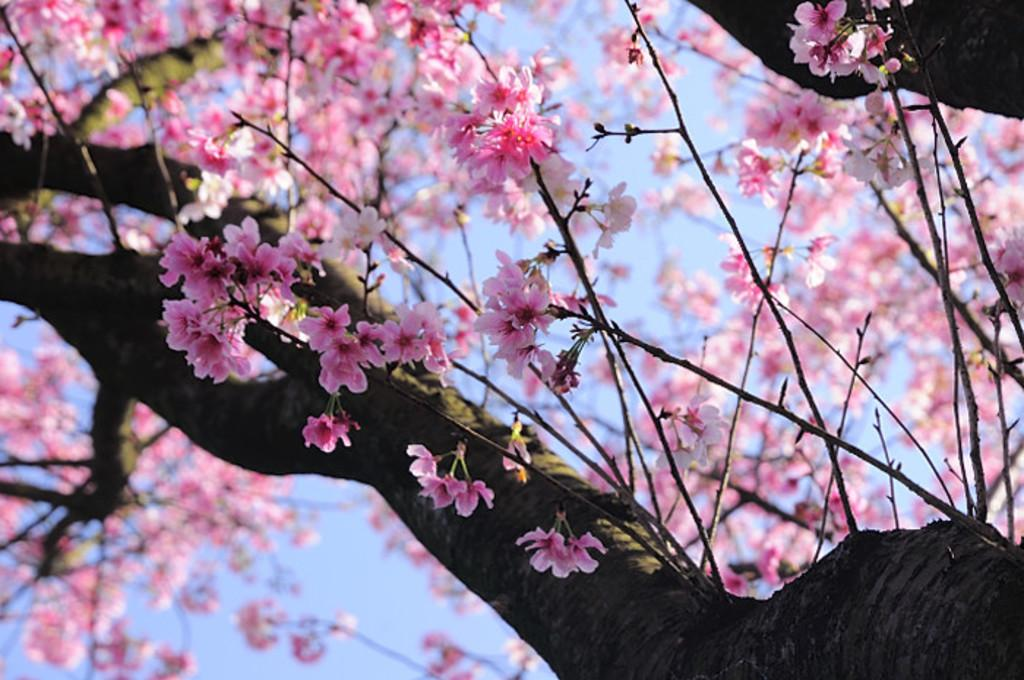What is present in the image? There is a tree in the image. What can be observed about the tree? The tree has pink color flowers. What is visible in the background of the image? The sky is visible in the background of the image. Can you see a tiger climbing the tree in the image? There is no tiger present in the image, and therefore no such activity can be observed. How many cents are visible in the image? There are no cents present in the image. 